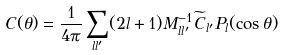<formula> <loc_0><loc_0><loc_500><loc_500>C ( \theta ) = \frac { 1 } { 4 \pi } \sum _ { l l ^ { \prime } } ( 2 l + 1 ) M _ { l l ^ { \prime } } ^ { - 1 } \widetilde { C } _ { l ^ { \prime } } P _ { l } ( \cos \theta )</formula> 